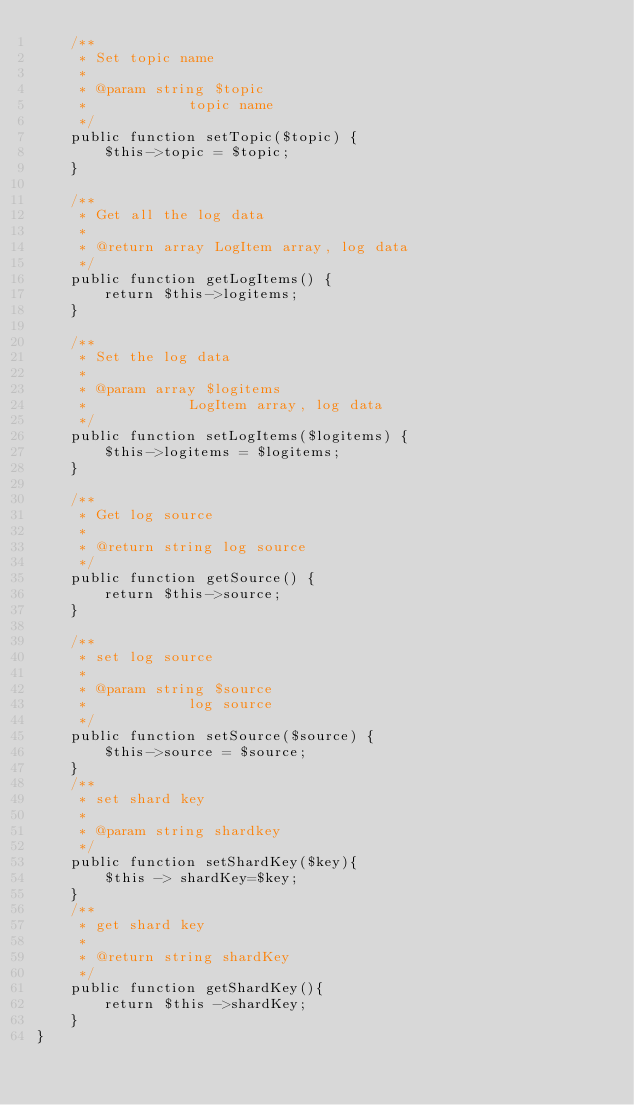Convert code to text. <code><loc_0><loc_0><loc_500><loc_500><_PHP_>    /**
     * Set topic name
     *
     * @param string $topic
     *            topic name
     */
    public function setTopic($topic) {
        $this->topic = $topic;
    }
    
    /**
     * Get all the log data
     * 
     * @return array LogItem array, log data
     */
    public function getLogItems() {
        return $this->logitems;
    }
    
    /**
     * Set the log data
     * 
     * @param array $logitems
     *            LogItem array, log data
     */
    public function setLogItems($logitems) {
        $this->logitems = $logitems;
    }
    
    /**
     * Get log source
     *
     * @return string log source
     */
    public function getSource() {
        return $this->source;
    }
    
    /**
     * set log source
     *
     * @param string $source
     *            log source
     */
    public function setSource($source) {
        $this->source = $source;
    }
    /**
     * set shard key
     *
     * @param string shardkey
     */
    public function setShardKey($key){
        $this -> shardKey=$key;
    }
    /**
     * get shard key
     *
     * @return string shardKey
     */
    public function getShardKey(){
        return $this ->shardKey;
    }
}
</code> 